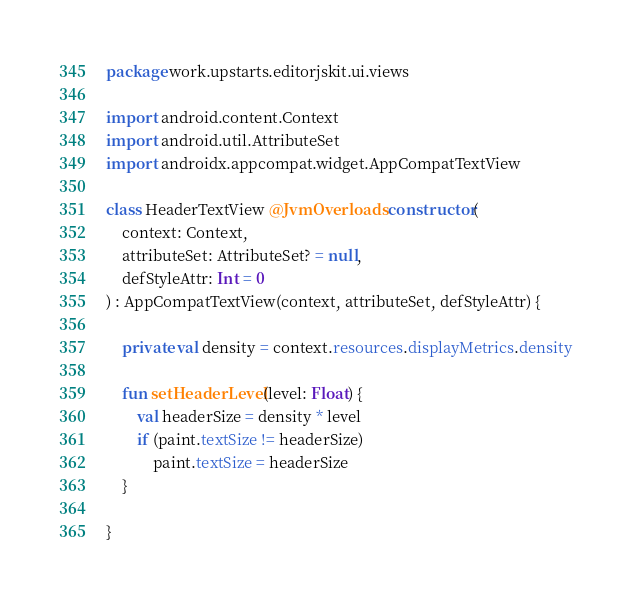Convert code to text. <code><loc_0><loc_0><loc_500><loc_500><_Kotlin_>package work.upstarts.editorjskit.ui.views

import android.content.Context
import android.util.AttributeSet
import androidx.appcompat.widget.AppCompatTextView

class HeaderTextView @JvmOverloads constructor(
    context: Context,
    attributeSet: AttributeSet? = null,
    defStyleAttr: Int = 0
) : AppCompatTextView(context, attributeSet, defStyleAttr) {

    private val density = context.resources.displayMetrics.density

    fun setHeaderLevel(level: Float) {
        val headerSize = density * level
        if (paint.textSize != headerSize)
            paint.textSize = headerSize
    }

}</code> 